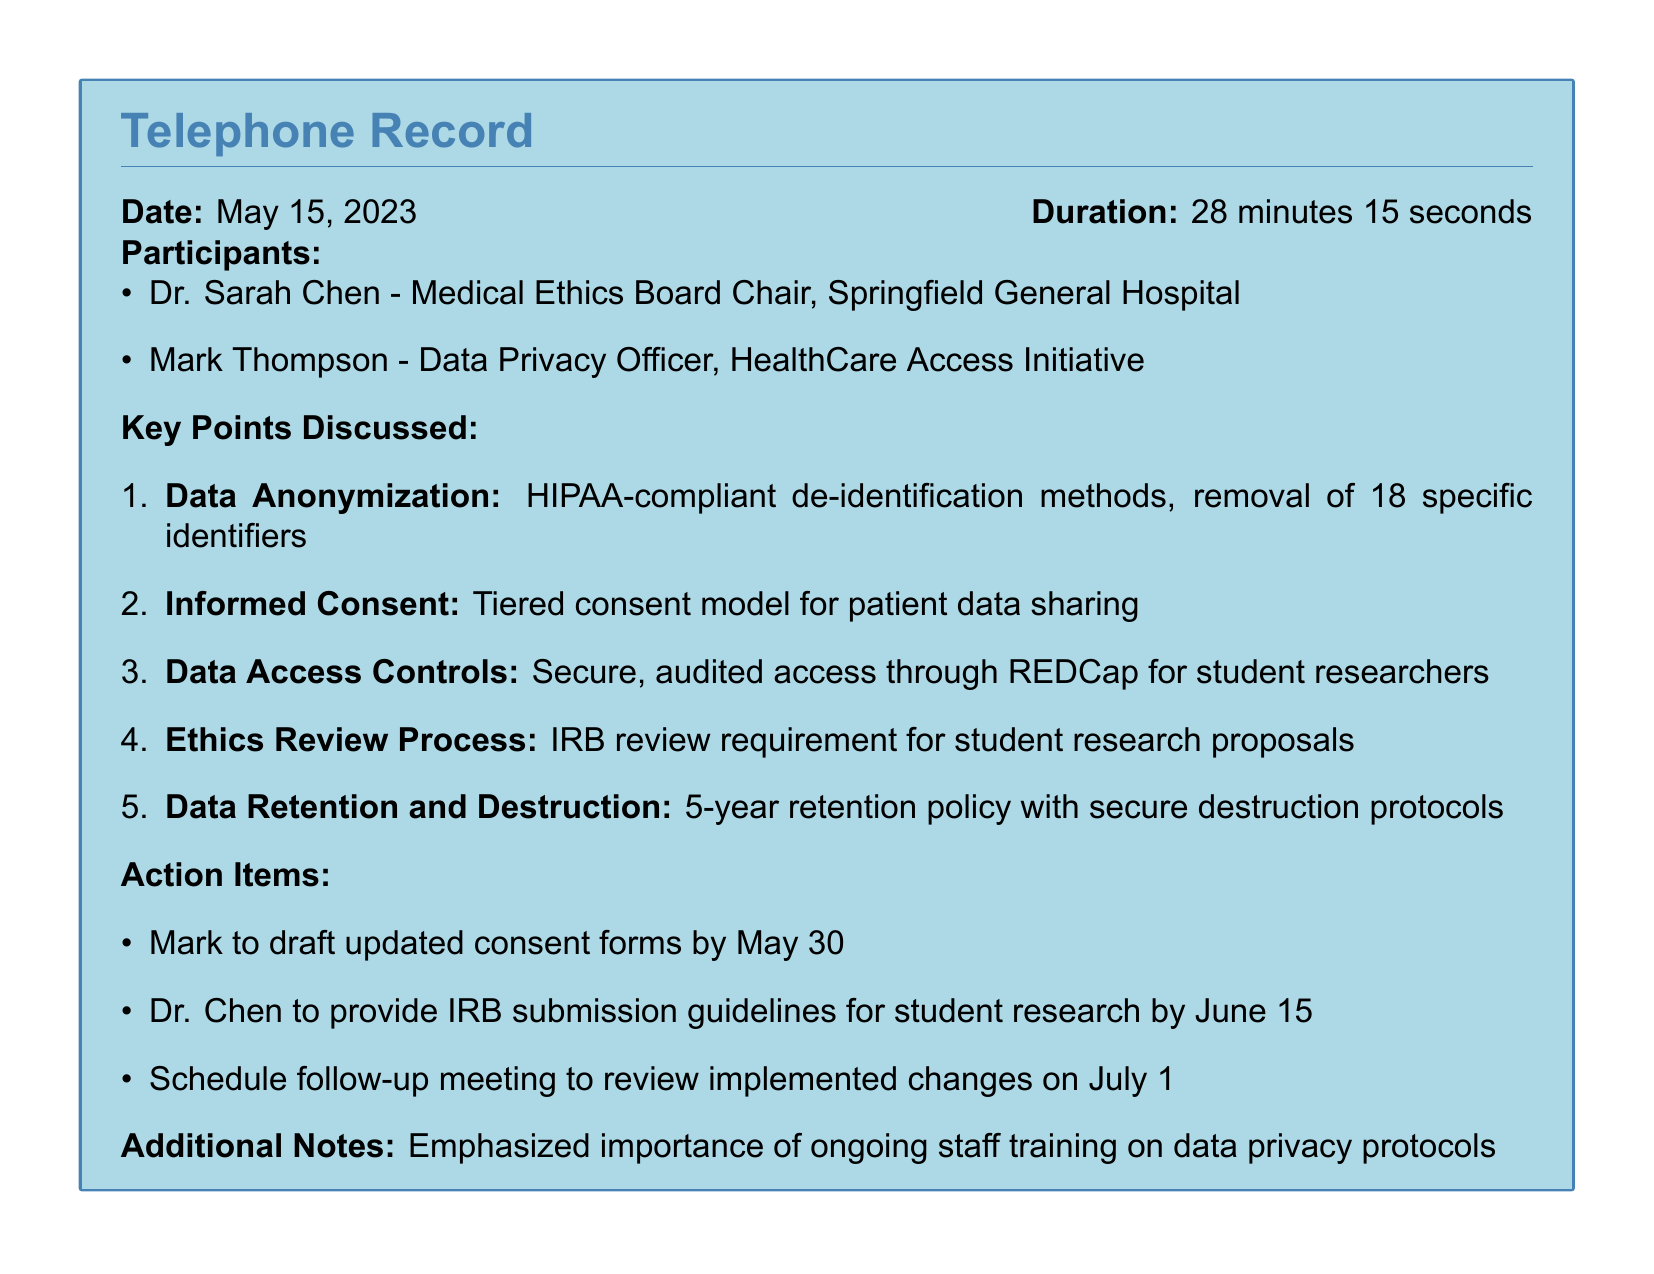What is the date of the telephone record? The date is explicitly stated at the beginning of the document.
Answer: May 15, 2023 Who is the Medical Ethics Board Chair? The name of the chair is listed under the participants section.
Answer: Dr. Sarah Chen What is the duration of the phone conversation? The duration is noted alongside the date in the document.
Answer: 28 minutes 15 seconds How many specific identifiers must be removed for data anonymization? The document mentions a specific number related to data anonymization.
Answer: 18 What is the action item due by May 30? This is stated in the action items section of the document.
Answer: Draft updated consent forms What is the data retention policy period? The retention policy is clearly outlined in the key points discussed.
Answer: 5-year What process is required for student research proposals? The document references a process that must be followed for research proposals.
Answer: IRB review What is the primary concern emphasized in the additional notes? The notes sections highlight the importance of ongoing training related to data privacy.
Answer: Ongoing staff training What platform will be used for secure access by student researchers? The relevant section indicates the platform intended for this purpose.
Answer: REDCap 